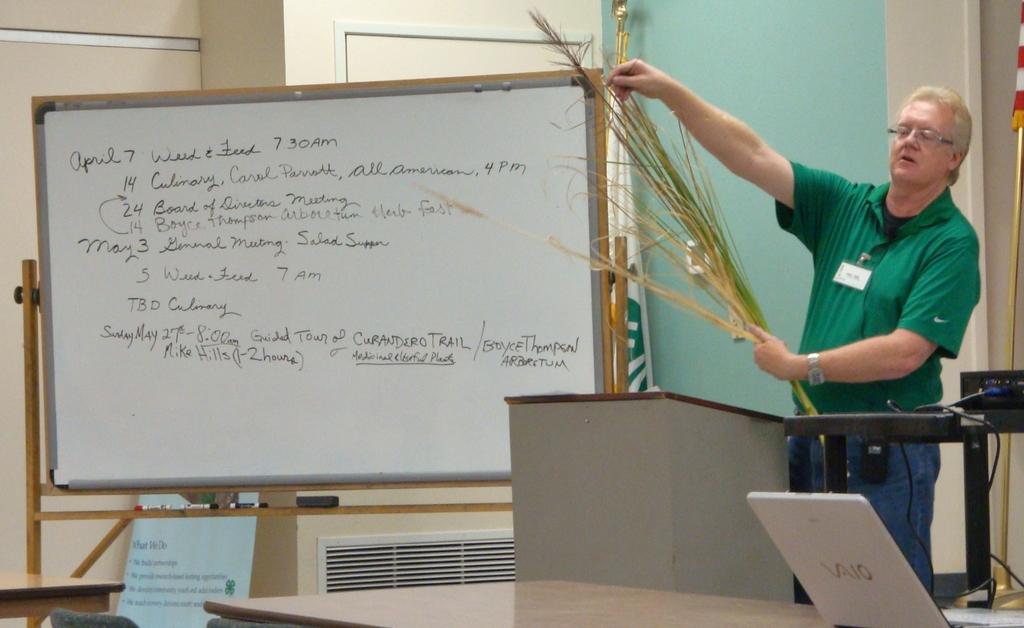What is the brand of the laptop?
Your response must be concise. Vaio. 